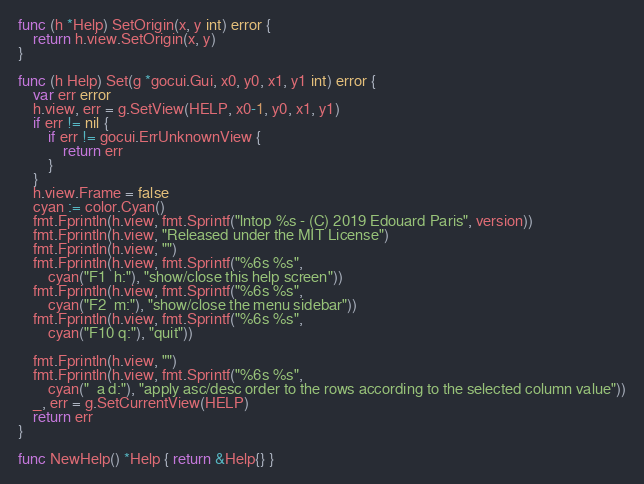Convert code to text. <code><loc_0><loc_0><loc_500><loc_500><_Go_>
func (h *Help) SetOrigin(x, y int) error {
	return h.view.SetOrigin(x, y)
}

func (h Help) Set(g *gocui.Gui, x0, y0, x1, y1 int) error {
	var err error
	h.view, err = g.SetView(HELP, x0-1, y0, x1, y1)
	if err != nil {
		if err != gocui.ErrUnknownView {
			return err
		}
	}
	h.view.Frame = false
	cyan := color.Cyan()
	fmt.Fprintln(h.view, fmt.Sprintf("lntop %s - (C) 2019 Edouard Paris", version))
	fmt.Fprintln(h.view, "Released under the MIT License")
	fmt.Fprintln(h.view, "")
	fmt.Fprintln(h.view, fmt.Sprintf("%6s %s",
		cyan("F1  h:"), "show/close this help screen"))
	fmt.Fprintln(h.view, fmt.Sprintf("%6s %s",
		cyan("F2  m:"), "show/close the menu sidebar"))
	fmt.Fprintln(h.view, fmt.Sprintf("%6s %s",
		cyan("F10 q:"), "quit"))

	fmt.Fprintln(h.view, "")
	fmt.Fprintln(h.view, fmt.Sprintf("%6s %s",
		cyan("  a d:"), "apply asc/desc order to the rows according to the selected column value"))
	_, err = g.SetCurrentView(HELP)
	return err
}

func NewHelp() *Help { return &Help{} }
</code> 